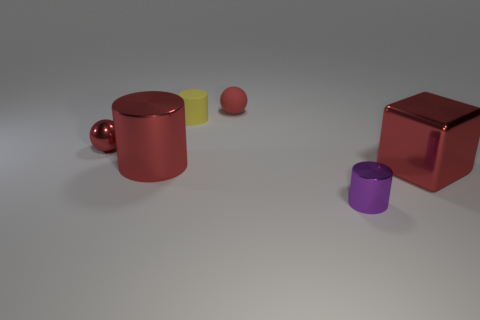What number of big red metallic objects are the same shape as the small red rubber thing?
Keep it short and to the point. 0. What number of red things are both behind the red metal cylinder and to the left of the matte cylinder?
Provide a succinct answer. 1. The big cylinder is what color?
Your answer should be very brief. Red. Are there any small balls that have the same material as the purple cylinder?
Your answer should be compact. Yes. There is a sphere that is behind the small red object on the left side of the tiny matte sphere; are there any small purple objects behind it?
Provide a succinct answer. No. Are there any tiny red rubber balls in front of the purple thing?
Ensure brevity in your answer.  No. Are there any other large cylinders of the same color as the rubber cylinder?
Offer a terse response. No. How many tiny things are yellow rubber cylinders or metallic things?
Offer a very short reply. 3. Are the tiny thing that is behind the yellow matte cylinder and the purple thing made of the same material?
Give a very brief answer. No. There is a tiny shiny object that is behind the red metal object that is on the right side of the small metallic thing that is on the right side of the big red cylinder; what shape is it?
Keep it short and to the point. Sphere. 